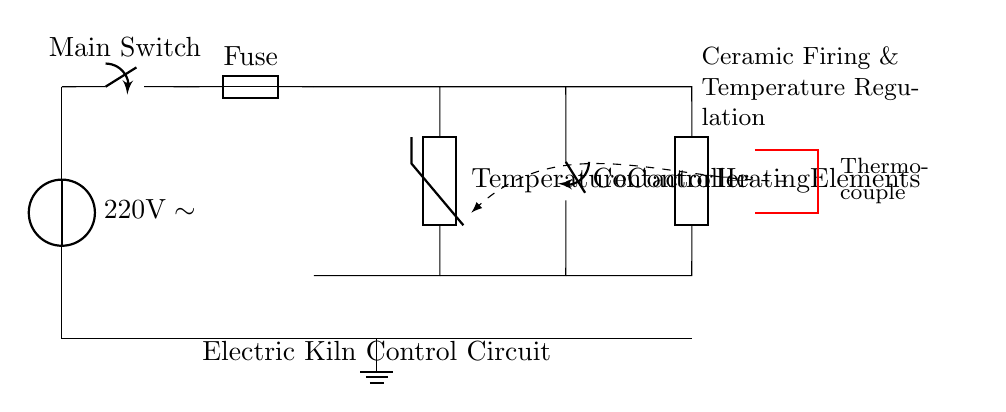What is the main voltage supply for the circuit? The main voltage supply is indicated at the top left corner of the circuit as a voltage source labeled with 220 volts AC, meaning that's the operational voltage for the electric kiln.
Answer: 220 volts What is the role of the thermistor in this circuit? The thermistor is shown connected to the temperature controller, which implies that it is used for temperature sensing and feedback for regulating the kiln's temperature during operation.
Answer: Temperature sensing How many major components are present in the circuit? By counting, we observe the main switch, fuse, temperature controller, contactor, heating elements, ground, and thermocouple. There are seven distinct components in total.
Answer: Seven What is the purpose of the fuse in the circuit? The fuse is usually included for overcurrent protection; it will break the circuit if the current exceeds safe levels, protecting the other components from damage.
Answer: Overcurrent protection What type of circuit is represented in this diagram? Since the circuit involves high power for heating elements and includes components to control and regulate temperature, it can be classified as an electric kiln control circuit, specifically for ceramic firing.
Answer: Electric kiln control circuit What does the dashed line connecting the thermocouple and temperature controller indicate? The dashed line represents a control loop where the thermocouple provides real-time temperature data to the temperature controller, allowing adjustments based on the sensed temperature.
Answer: Control loop What is the function of the contactor in the kiln's operation? The contactor acts as an electrically controlled switch that enables or disables the current flow to the heating elements based on the output from the temperature controller.
Answer: Switch for heating elements 